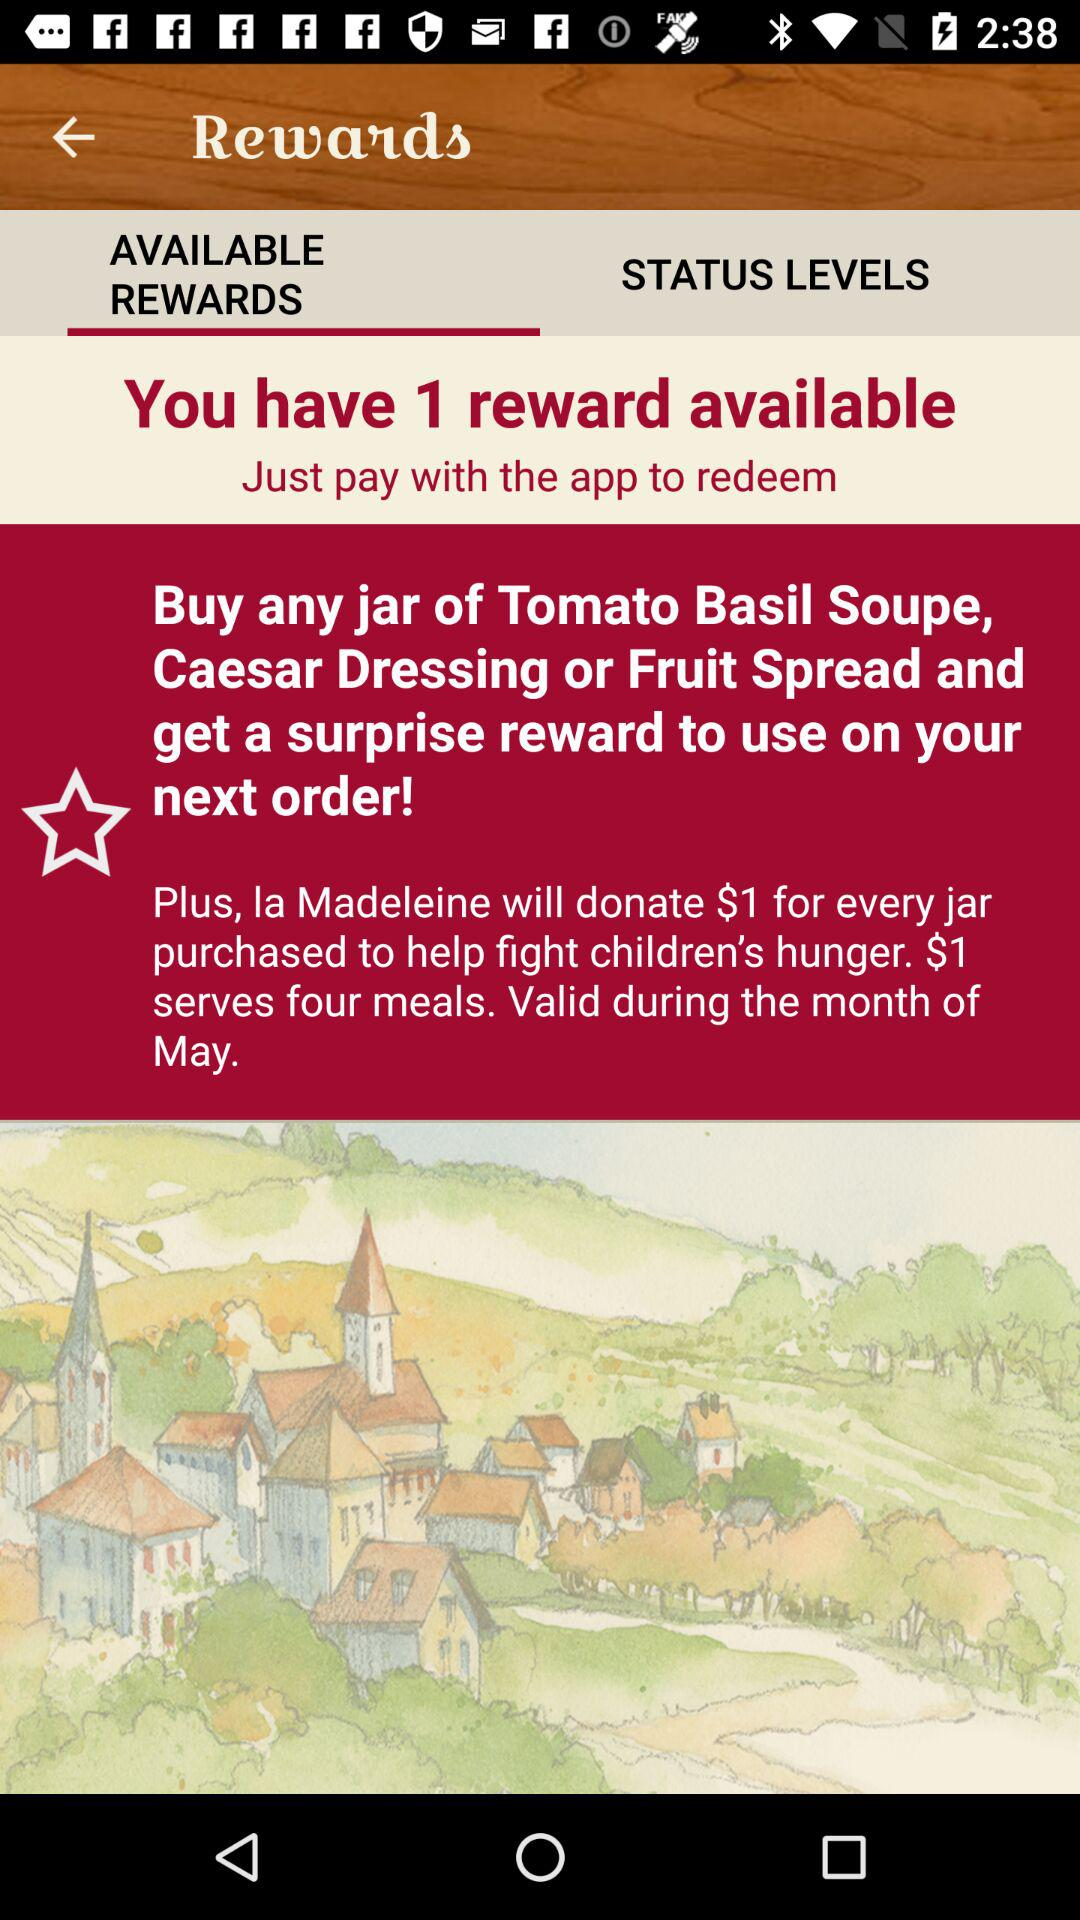How many rewards do I have available?
Answer the question using a single word or phrase. 1 